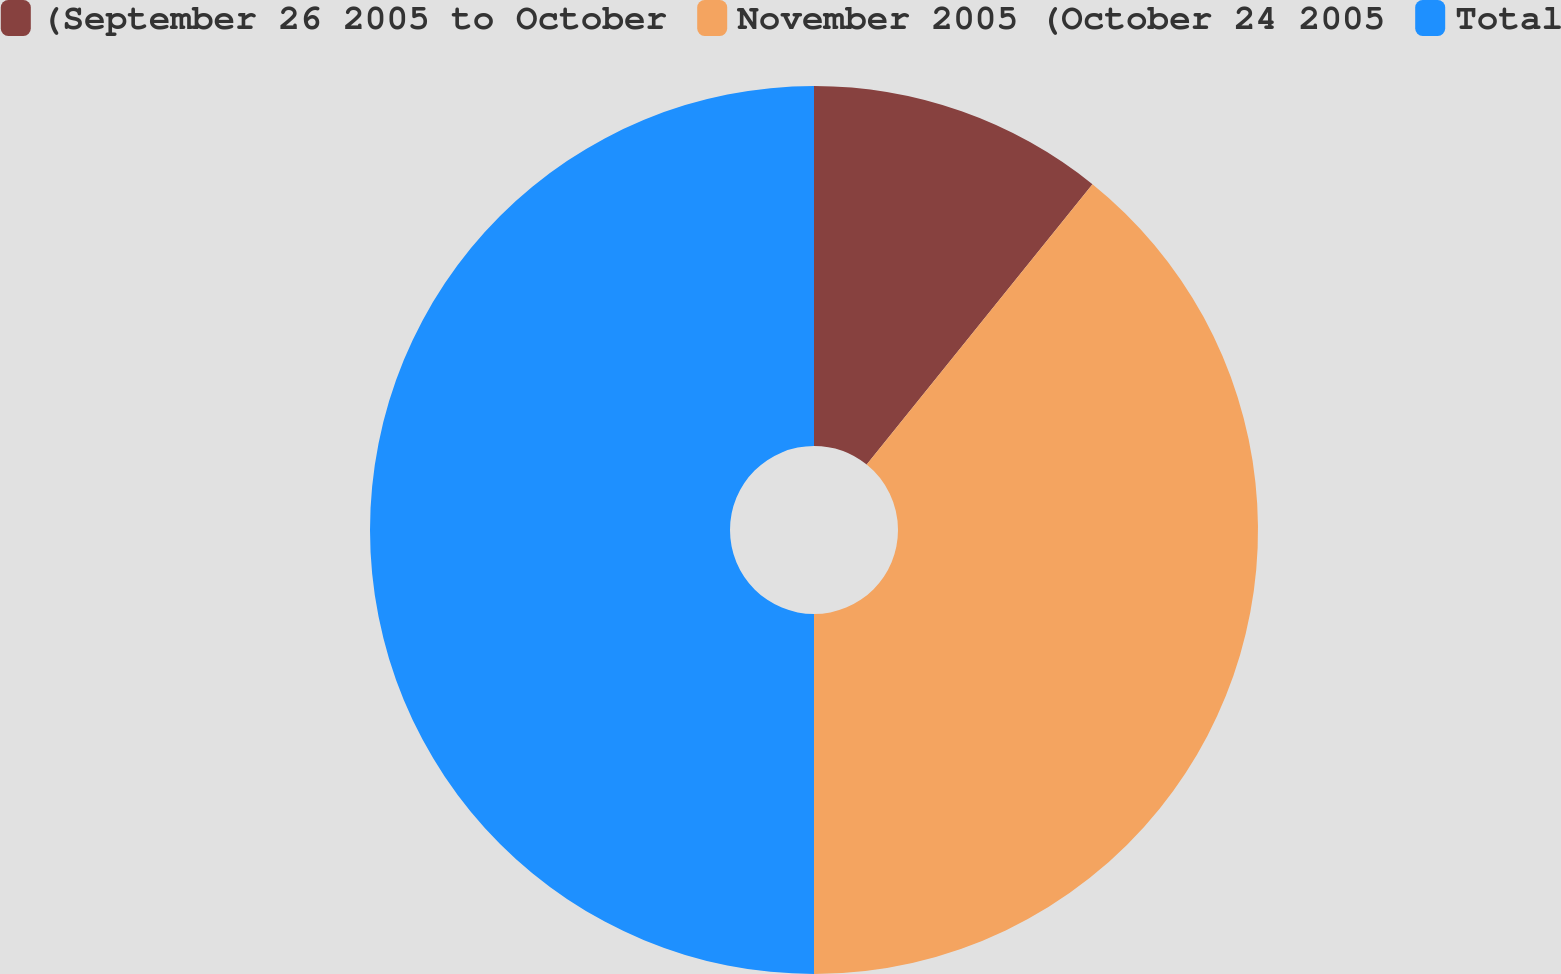Convert chart to OTSL. <chart><loc_0><loc_0><loc_500><loc_500><pie_chart><fcel>(September 26 2005 to October<fcel>November 2005 (October 24 2005<fcel>Total<nl><fcel>10.79%<fcel>39.21%<fcel>50.0%<nl></chart> 